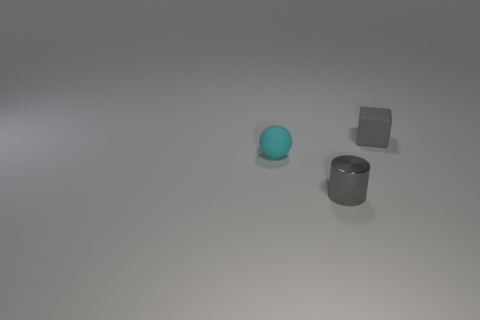Add 1 gray blocks. How many objects exist? 4 Subtract all balls. How many objects are left? 2 Add 3 small gray things. How many small gray things exist? 5 Subtract 0 yellow cubes. How many objects are left? 3 Subtract all cyan rubber balls. Subtract all gray metallic things. How many objects are left? 1 Add 1 tiny gray blocks. How many tiny gray blocks are left? 2 